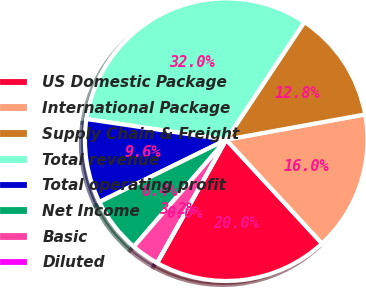Convert chart. <chart><loc_0><loc_0><loc_500><loc_500><pie_chart><fcel>US Domestic Package<fcel>International Package<fcel>Supply Chain & Freight<fcel>Total revenue<fcel>Total operating profit<fcel>Net Income<fcel>Basic<fcel>Diluted<nl><fcel>19.99%<fcel>16.0%<fcel>12.8%<fcel>32.0%<fcel>9.6%<fcel>6.4%<fcel>3.2%<fcel>0.0%<nl></chart> 